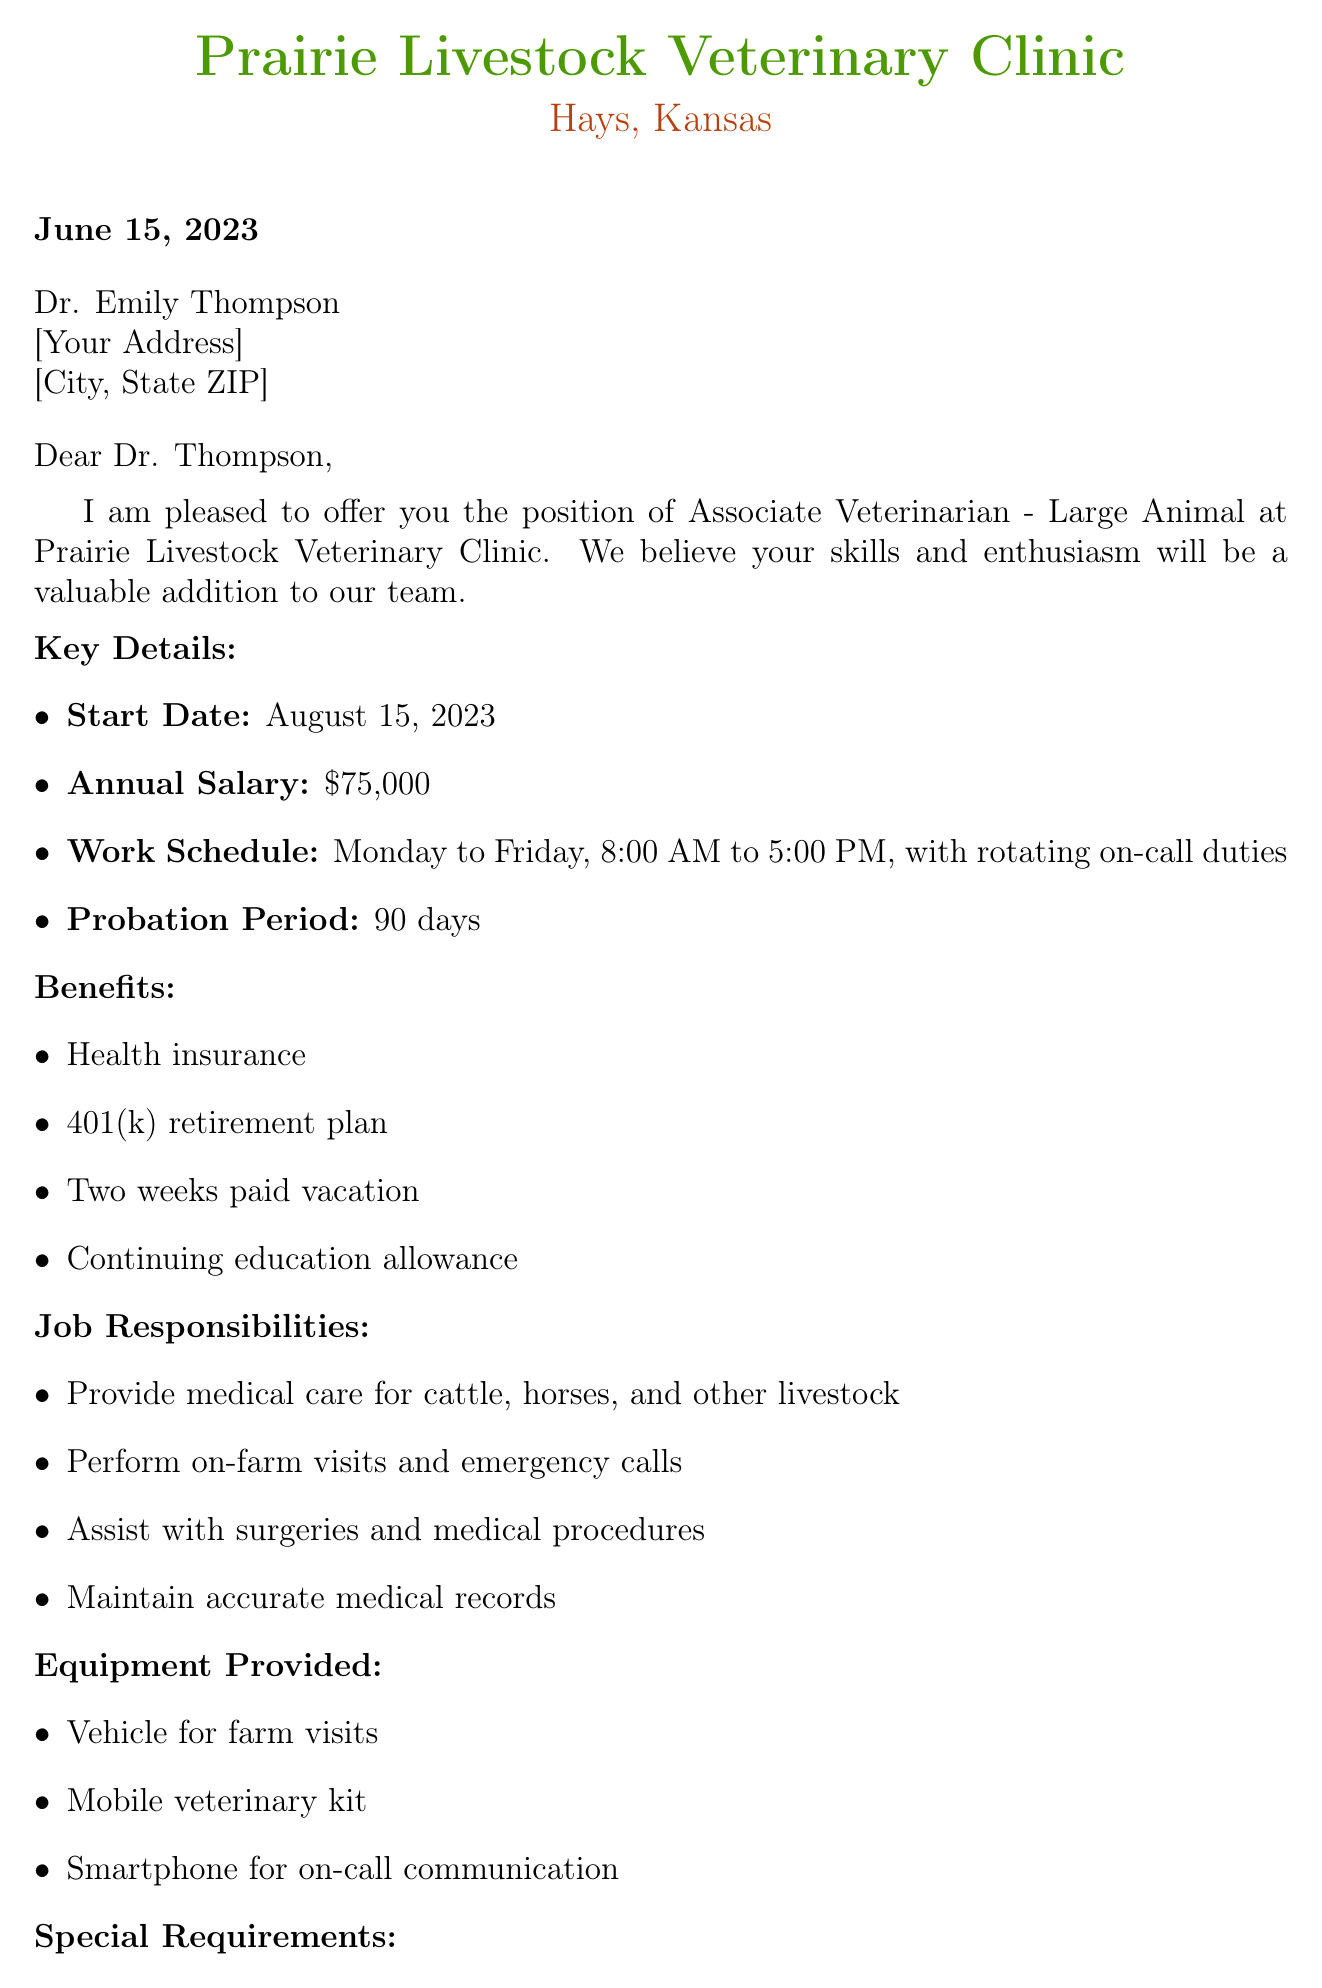What is the name of the clinic? The clinic is named Prairie Livestock Veterinary Clinic, as stated in the document.
Answer: Prairie Livestock Veterinary Clinic Who is the recipient of the job offer? The job offer is addressed to Dr. Emily Thompson, as mentioned in the greeting.
Answer: Dr. Emily Thompson What is the annual salary for the position? The salary detail in the document states the annual salary is $75,000.
Answer: $75,000 What is the start date for the position? The start date mentioned in the key details is August 15, 2023.
Answer: August 15, 2023 What are the working hours for the job? The work schedule outlines the working hours as Monday to Friday, 8:00 AM to 5:00 PM.
Answer: Monday to Friday, 8:00 AM to 5:00 PM What is the duration of the probation period? The document specifies that the probation period lasts for 90 days.
Answer: 90 days What kind of insurance is provided as part of the benefits? The benefits include health insurance as per the list in the document.
Answer: Health insurance What special requirement is related to relocating? The document states a willingness to relocate to Hays, Kansas, is a special requirement.
Answer: Willingness to relocate to Hays, Kansas How many weeks of paid vacation are offered? According to the benefits section, two weeks of paid vacation are offered.
Answer: Two weeks paid vacation 